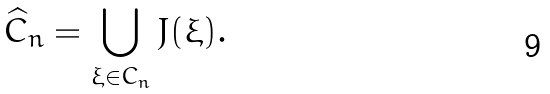<formula> <loc_0><loc_0><loc_500><loc_500>\widehat { C } _ { n } = \bigcup _ { \xi \in C _ { n } } J ( \xi ) .</formula> 